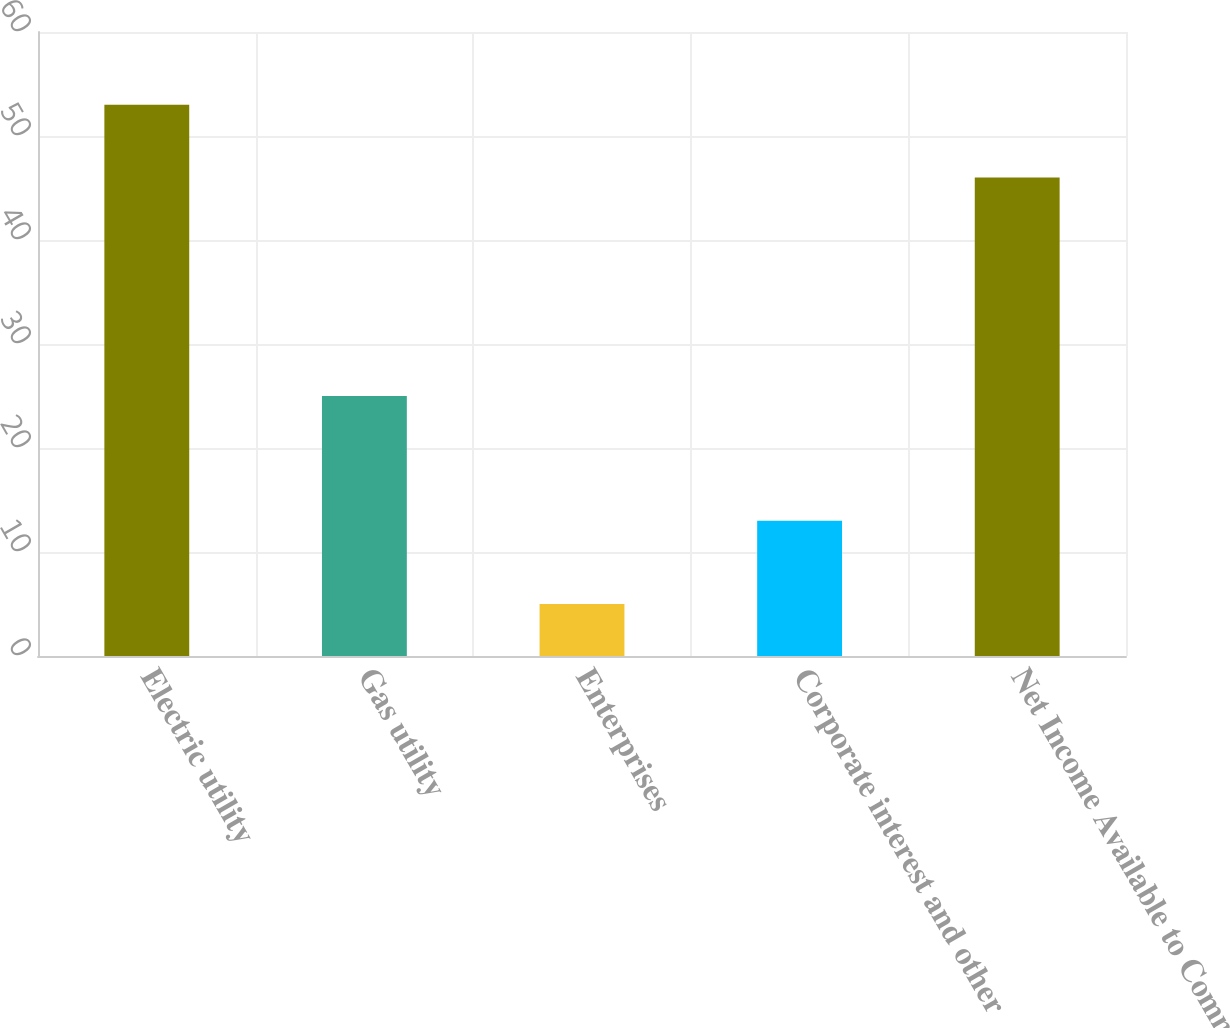Convert chart to OTSL. <chart><loc_0><loc_0><loc_500><loc_500><bar_chart><fcel>Electric utility<fcel>Gas utility<fcel>Enterprises<fcel>Corporate interest and other<fcel>Net Income Available to Common<nl><fcel>53<fcel>25<fcel>5<fcel>13<fcel>46<nl></chart> 